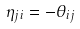Convert formula to latex. <formula><loc_0><loc_0><loc_500><loc_500>\eta _ { j i } = - \theta _ { i j }</formula> 